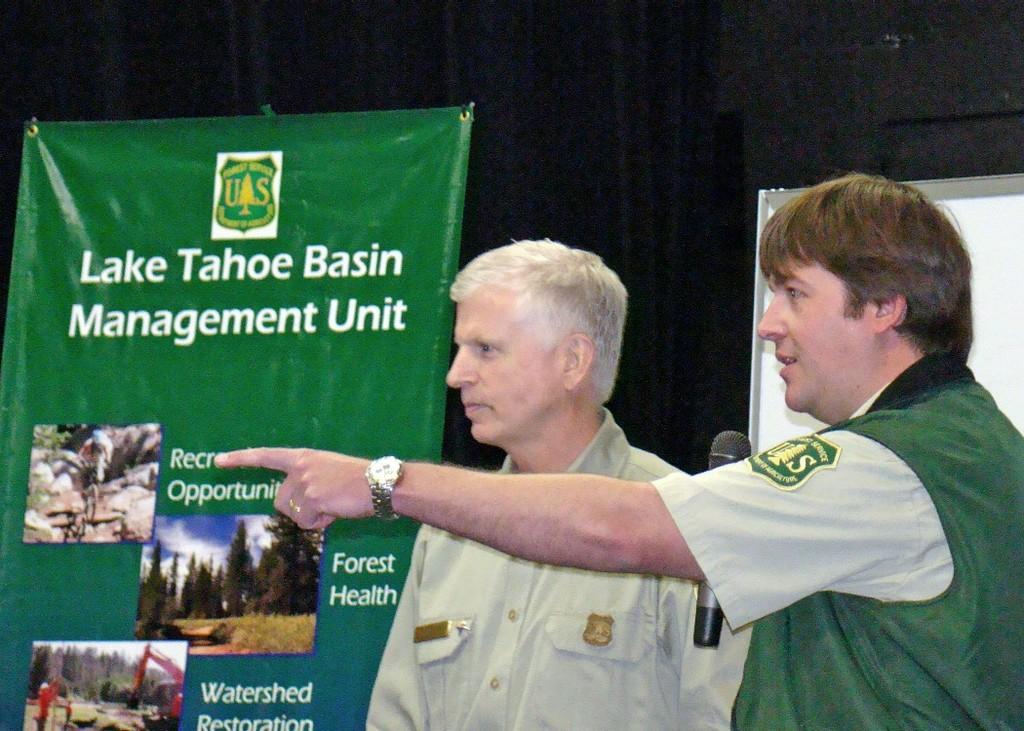How would you summarize this image in a sentence or two? As we can see in the image there are two people standing in the front and there are banners. The man standing on the right side is holding a mic. 